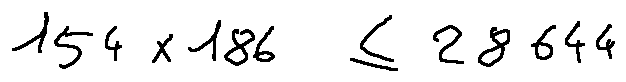<formula> <loc_0><loc_0><loc_500><loc_500>1 5 4 \times 1 8 6 \leq 2 8 6 4 4</formula> 